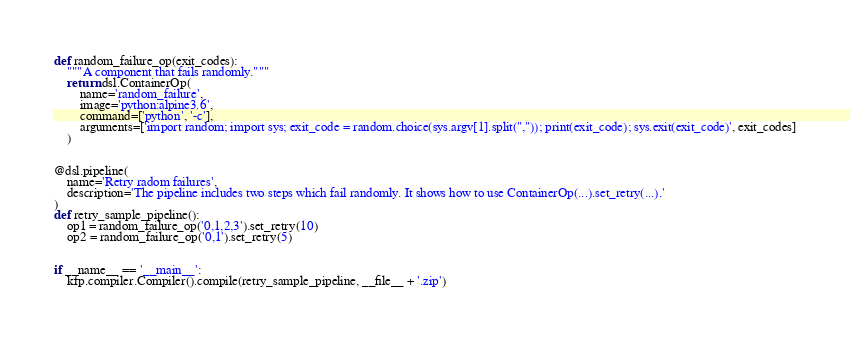<code> <loc_0><loc_0><loc_500><loc_500><_Python_>def random_failure_op(exit_codes):
    """A component that fails randomly."""
    return dsl.ContainerOp(
        name='random_failure',
        image='python:alpine3.6',
        command=['python', '-c'],
        arguments=['import random; import sys; exit_code = random.choice(sys.argv[1].split(",")); print(exit_code); sys.exit(exit_code)', exit_codes]
    )


@dsl.pipeline(
    name='Retry radom failures',
    description='The pipeline includes two steps which fail randomly. It shows how to use ContainerOp(...).set_retry(...).'
)
def retry_sample_pipeline():
    op1 = random_failure_op('0,1,2,3').set_retry(10)
    op2 = random_failure_op('0,1').set_retry(5)


if __name__ == '__main__':
    kfp.compiler.Compiler().compile(retry_sample_pipeline, __file__ + '.zip')
</code> 